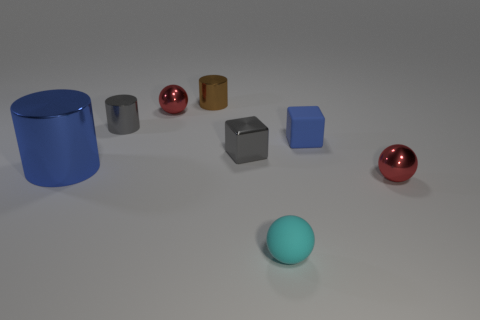Subtract all cyan matte spheres. How many spheres are left? 2 Subtract 1 balls. How many balls are left? 2 Add 1 gray rubber blocks. How many objects exist? 9 Subtract all cylinders. How many objects are left? 5 Subtract 0 purple cylinders. How many objects are left? 8 Subtract all cyan spheres. Subtract all brown cylinders. How many objects are left? 6 Add 8 blue metallic cylinders. How many blue metallic cylinders are left? 9 Add 4 balls. How many balls exist? 7 